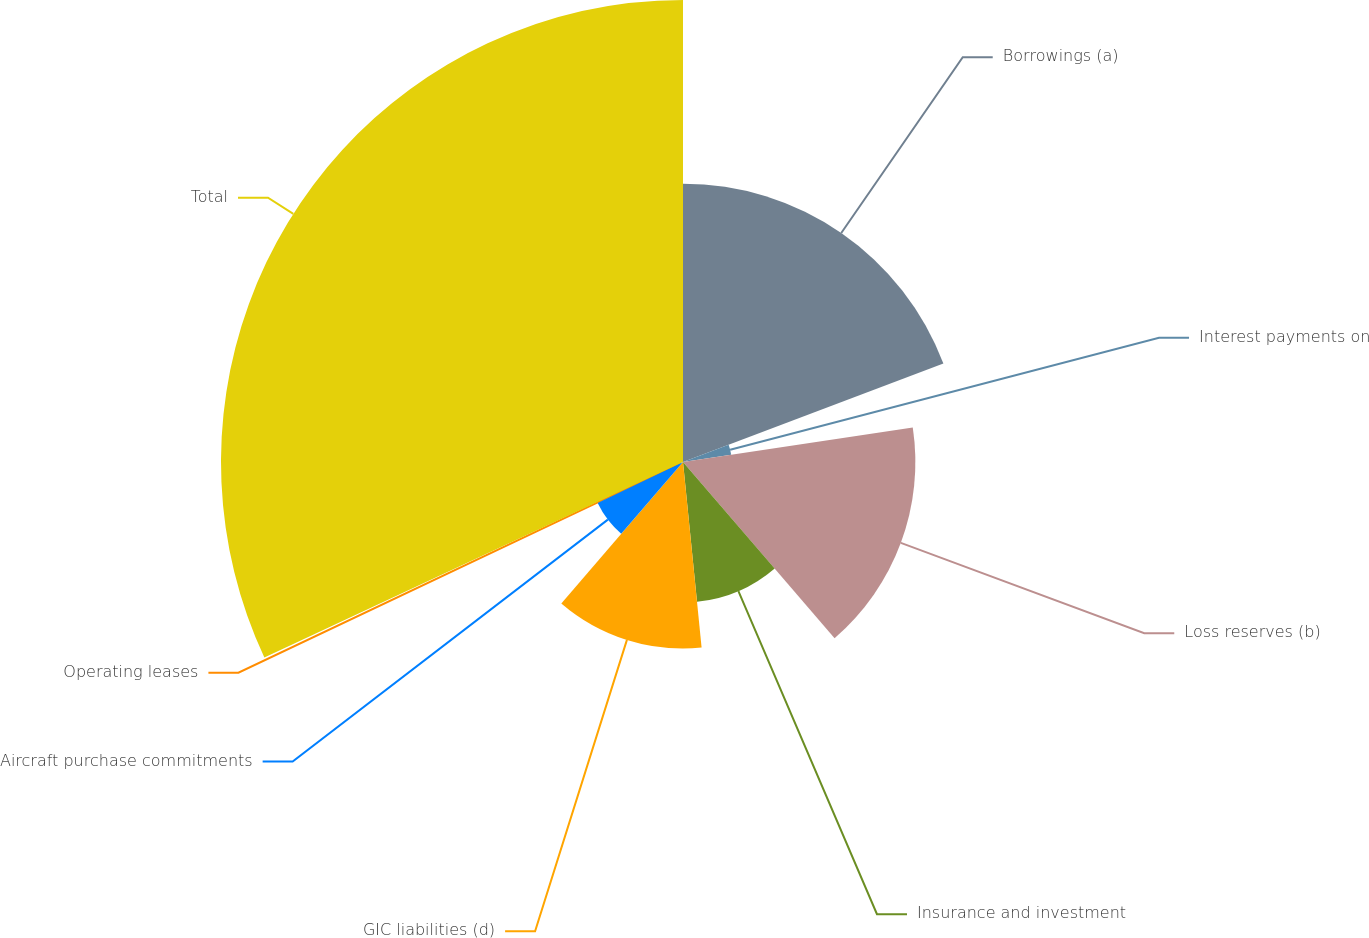Convert chart to OTSL. <chart><loc_0><loc_0><loc_500><loc_500><pie_chart><fcel>Borrowings (a)<fcel>Interest payments on<fcel>Loss reserves (b)<fcel>Insurance and investment<fcel>GIC liabilities (d)<fcel>Aircraft purchase commitments<fcel>Operating leases<fcel>Total<nl><fcel>19.25%<fcel>3.37%<fcel>16.07%<fcel>9.72%<fcel>12.9%<fcel>6.55%<fcel>0.19%<fcel>31.95%<nl></chart> 